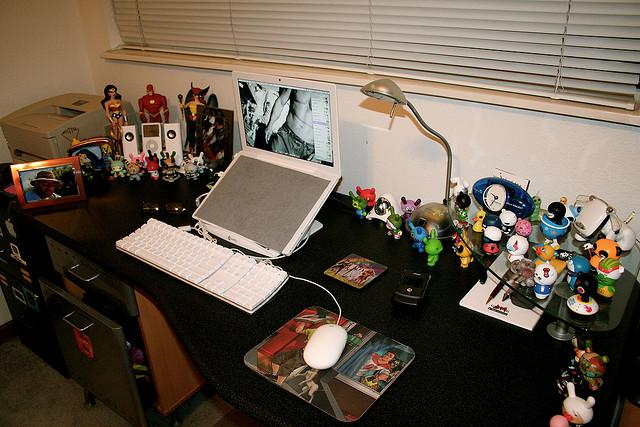Which female superhero is on the left corner of the desk? Please explain your reasoning. wonder woman. Has a blue red and white patriotic uniform on her. 